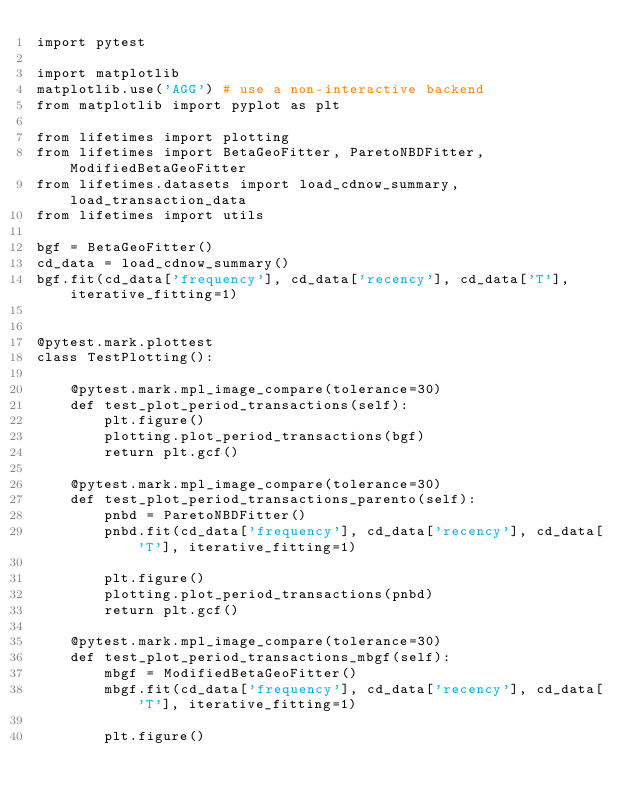<code> <loc_0><loc_0><loc_500><loc_500><_Python_>import pytest

import matplotlib
matplotlib.use('AGG') # use a non-interactive backend
from matplotlib import pyplot as plt

from lifetimes import plotting
from lifetimes import BetaGeoFitter, ParetoNBDFitter, ModifiedBetaGeoFitter
from lifetimes.datasets import load_cdnow_summary, load_transaction_data
from lifetimes import utils

bgf = BetaGeoFitter()
cd_data = load_cdnow_summary()
bgf.fit(cd_data['frequency'], cd_data['recency'], cd_data['T'], iterative_fitting=1)


@pytest.mark.plottest
class TestPlotting():

    @pytest.mark.mpl_image_compare(tolerance=30)
    def test_plot_period_transactions(self):
        plt.figure()
        plotting.plot_period_transactions(bgf)
        return plt.gcf()

    @pytest.mark.mpl_image_compare(tolerance=30)
    def test_plot_period_transactions_parento(self):
        pnbd = ParetoNBDFitter()
        pnbd.fit(cd_data['frequency'], cd_data['recency'], cd_data['T'], iterative_fitting=1)

        plt.figure()
        plotting.plot_period_transactions(pnbd)
        return plt.gcf()

    @pytest.mark.mpl_image_compare(tolerance=30)
    def test_plot_period_transactions_mbgf(self):
        mbgf = ModifiedBetaGeoFitter()
        mbgf.fit(cd_data['frequency'], cd_data['recency'], cd_data['T'], iterative_fitting=1)

        plt.figure()</code> 